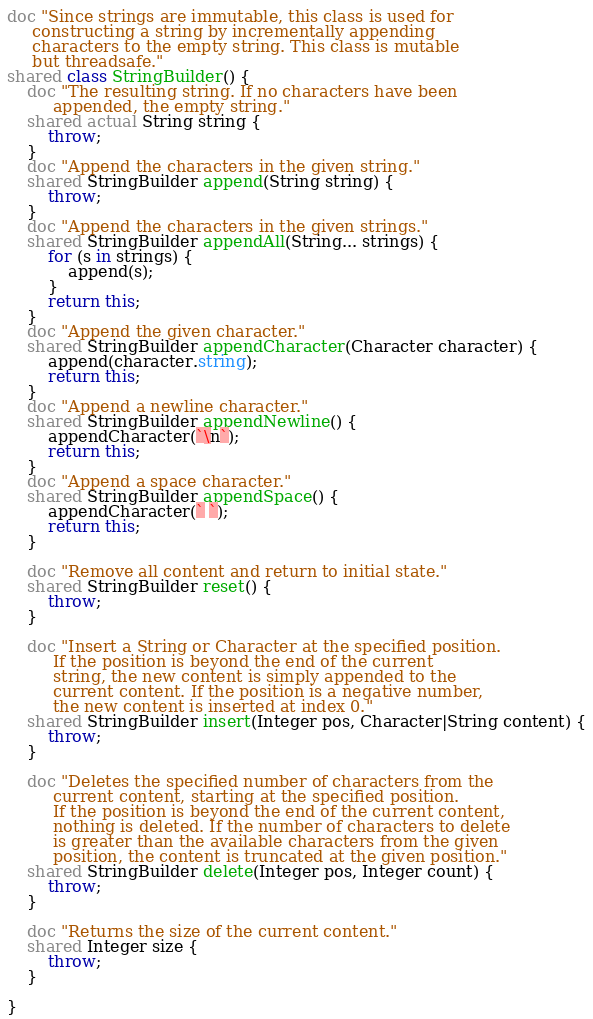Convert code to text. <code><loc_0><loc_0><loc_500><loc_500><_Ceylon_>doc "Since strings are immutable, this class is used for
     constructing a string by incrementally appending 
     characters to the empty string. This class is mutable 
     but threadsafe."
shared class StringBuilder() {
    doc "The resulting string. If no characters have been
         appended, the empty string."
    shared actual String string { 
        throw; 
    }
    doc "Append the characters in the given string."
    shared StringBuilder append(String string) {
        throw;
    }
    doc "Append the characters in the given strings."
    shared StringBuilder appendAll(String... strings) {
        for (s in strings) {
            append(s);
        }
        return this;
    }
    doc "Append the given character."
    shared StringBuilder appendCharacter(Character character) {
        append(character.string);
        return this;
    }
    doc "Append a newline character."
    shared StringBuilder appendNewline() {
        appendCharacter(`\n`);
        return this;
    }
    doc "Append a space character."
    shared StringBuilder appendSpace() {
        appendCharacter(` `);
        return this;
    }

    doc "Remove all content and return to initial state."
    shared StringBuilder reset() {
        throw;
    }

    doc "Insert a String or Character at the specified position.
         If the position is beyond the end of the current
         string, the new content is simply appended to the
         current content. If the position is a negative number,
         the new content is inserted at index 0."
    shared StringBuilder insert(Integer pos, Character|String content) {
        throw;
    }

    doc "Deletes the specified number of characters from the
         current content, starting at the specified position.
         If the position is beyond the end of the current content,
         nothing is deleted. If the number of characters to delete
         is greater than the available characters from the given
         position, the content is truncated at the given position."
    shared StringBuilder delete(Integer pos, Integer count) {
        throw;
    }

    doc "Returns the size of the current content."
    shared Integer size {
        throw;
    }

}</code> 